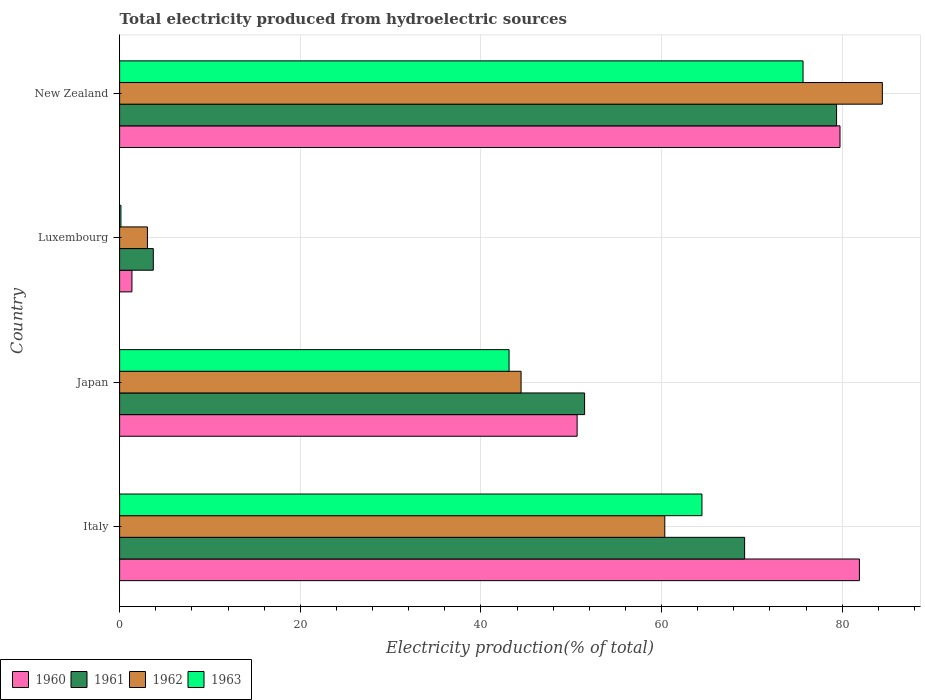How many different coloured bars are there?
Your answer should be very brief. 4. How many groups of bars are there?
Make the answer very short. 4. Are the number of bars per tick equal to the number of legend labels?
Your answer should be compact. Yes. Are the number of bars on each tick of the Y-axis equal?
Offer a terse response. Yes. How many bars are there on the 1st tick from the top?
Offer a terse response. 4. How many bars are there on the 2nd tick from the bottom?
Keep it short and to the point. 4. What is the total electricity produced in 1961 in Italy?
Ensure brevity in your answer.  69.19. Across all countries, what is the maximum total electricity produced in 1962?
Give a very brief answer. 84.44. Across all countries, what is the minimum total electricity produced in 1962?
Make the answer very short. 3.08. In which country was the total electricity produced in 1960 maximum?
Your answer should be very brief. Italy. In which country was the total electricity produced in 1961 minimum?
Offer a very short reply. Luxembourg. What is the total total electricity produced in 1961 in the graph?
Give a very brief answer. 203.77. What is the difference between the total electricity produced in 1963 in Luxembourg and that in New Zealand?
Make the answer very short. -75.51. What is the difference between the total electricity produced in 1960 in Italy and the total electricity produced in 1961 in Luxembourg?
Your answer should be very brief. 78.17. What is the average total electricity produced in 1963 per country?
Offer a very short reply. 45.85. What is the difference between the total electricity produced in 1962 and total electricity produced in 1961 in New Zealand?
Offer a terse response. 5.07. In how many countries, is the total electricity produced in 1961 greater than 44 %?
Your response must be concise. 3. What is the ratio of the total electricity produced in 1961 in Italy to that in Luxembourg?
Offer a terse response. 18.55. What is the difference between the highest and the second highest total electricity produced in 1963?
Your answer should be very brief. 11.19. What is the difference between the highest and the lowest total electricity produced in 1960?
Offer a very short reply. 80.53. Is it the case that in every country, the sum of the total electricity produced in 1961 and total electricity produced in 1960 is greater than the sum of total electricity produced in 1963 and total electricity produced in 1962?
Provide a succinct answer. No. What does the 2nd bar from the top in Japan represents?
Your response must be concise. 1962. Is it the case that in every country, the sum of the total electricity produced in 1961 and total electricity produced in 1963 is greater than the total electricity produced in 1962?
Provide a short and direct response. Yes. How many bars are there?
Make the answer very short. 16. Are all the bars in the graph horizontal?
Give a very brief answer. Yes. How many countries are there in the graph?
Offer a very short reply. 4. What is the difference between two consecutive major ticks on the X-axis?
Keep it short and to the point. 20. Are the values on the major ticks of X-axis written in scientific E-notation?
Your answer should be very brief. No. Does the graph contain any zero values?
Your answer should be compact. No. What is the title of the graph?
Offer a very short reply. Total electricity produced from hydroelectric sources. Does "2009" appear as one of the legend labels in the graph?
Make the answer very short. No. What is the label or title of the X-axis?
Your response must be concise. Electricity production(% of total). What is the Electricity production(% of total) in 1960 in Italy?
Provide a succinct answer. 81.9. What is the Electricity production(% of total) in 1961 in Italy?
Make the answer very short. 69.19. What is the Electricity production(% of total) in 1962 in Italy?
Your response must be concise. 60.35. What is the Electricity production(% of total) of 1963 in Italy?
Your response must be concise. 64.47. What is the Electricity production(% of total) of 1960 in Japan?
Give a very brief answer. 50.65. What is the Electricity production(% of total) of 1961 in Japan?
Give a very brief answer. 51.48. What is the Electricity production(% of total) of 1962 in Japan?
Provide a short and direct response. 44.44. What is the Electricity production(% of total) of 1963 in Japan?
Your answer should be compact. 43.11. What is the Electricity production(% of total) in 1960 in Luxembourg?
Give a very brief answer. 1.37. What is the Electricity production(% of total) in 1961 in Luxembourg?
Provide a succinct answer. 3.73. What is the Electricity production(% of total) of 1962 in Luxembourg?
Provide a short and direct response. 3.08. What is the Electricity production(% of total) of 1963 in Luxembourg?
Provide a short and direct response. 0.15. What is the Electricity production(% of total) in 1960 in New Zealand?
Provide a succinct answer. 79.75. What is the Electricity production(% of total) of 1961 in New Zealand?
Offer a terse response. 79.37. What is the Electricity production(% of total) of 1962 in New Zealand?
Your response must be concise. 84.44. What is the Electricity production(% of total) in 1963 in New Zealand?
Offer a very short reply. 75.66. Across all countries, what is the maximum Electricity production(% of total) in 1960?
Offer a terse response. 81.9. Across all countries, what is the maximum Electricity production(% of total) of 1961?
Your answer should be compact. 79.37. Across all countries, what is the maximum Electricity production(% of total) in 1962?
Give a very brief answer. 84.44. Across all countries, what is the maximum Electricity production(% of total) of 1963?
Provide a short and direct response. 75.66. Across all countries, what is the minimum Electricity production(% of total) of 1960?
Offer a very short reply. 1.37. Across all countries, what is the minimum Electricity production(% of total) in 1961?
Keep it short and to the point. 3.73. Across all countries, what is the minimum Electricity production(% of total) of 1962?
Your answer should be compact. 3.08. Across all countries, what is the minimum Electricity production(% of total) of 1963?
Your response must be concise. 0.15. What is the total Electricity production(% of total) of 1960 in the graph?
Provide a succinct answer. 213.67. What is the total Electricity production(% of total) in 1961 in the graph?
Keep it short and to the point. 203.77. What is the total Electricity production(% of total) of 1962 in the graph?
Give a very brief answer. 192.32. What is the total Electricity production(% of total) of 1963 in the graph?
Your response must be concise. 183.39. What is the difference between the Electricity production(% of total) in 1960 in Italy and that in Japan?
Your answer should be compact. 31.25. What is the difference between the Electricity production(% of total) in 1961 in Italy and that in Japan?
Offer a very short reply. 17.71. What is the difference between the Electricity production(% of total) of 1962 in Italy and that in Japan?
Ensure brevity in your answer.  15.91. What is the difference between the Electricity production(% of total) of 1963 in Italy and that in Japan?
Your answer should be compact. 21.35. What is the difference between the Electricity production(% of total) of 1960 in Italy and that in Luxembourg?
Provide a succinct answer. 80.53. What is the difference between the Electricity production(% of total) of 1961 in Italy and that in Luxembourg?
Provide a succinct answer. 65.46. What is the difference between the Electricity production(% of total) in 1962 in Italy and that in Luxembourg?
Make the answer very short. 57.27. What is the difference between the Electricity production(% of total) in 1963 in Italy and that in Luxembourg?
Keep it short and to the point. 64.32. What is the difference between the Electricity production(% of total) in 1960 in Italy and that in New Zealand?
Offer a terse response. 2.15. What is the difference between the Electricity production(% of total) of 1961 in Italy and that in New Zealand?
Your answer should be compact. -10.18. What is the difference between the Electricity production(% of total) in 1962 in Italy and that in New Zealand?
Keep it short and to the point. -24.08. What is the difference between the Electricity production(% of total) of 1963 in Italy and that in New Zealand?
Provide a succinct answer. -11.19. What is the difference between the Electricity production(% of total) of 1960 in Japan and that in Luxembourg?
Provide a short and direct response. 49.28. What is the difference between the Electricity production(% of total) of 1961 in Japan and that in Luxembourg?
Your answer should be compact. 47.75. What is the difference between the Electricity production(% of total) in 1962 in Japan and that in Luxembourg?
Provide a succinct answer. 41.36. What is the difference between the Electricity production(% of total) in 1963 in Japan and that in Luxembourg?
Offer a terse response. 42.97. What is the difference between the Electricity production(% of total) of 1960 in Japan and that in New Zealand?
Keep it short and to the point. -29.1. What is the difference between the Electricity production(% of total) of 1961 in Japan and that in New Zealand?
Your answer should be very brief. -27.9. What is the difference between the Electricity production(% of total) of 1962 in Japan and that in New Zealand?
Offer a very short reply. -39.99. What is the difference between the Electricity production(% of total) of 1963 in Japan and that in New Zealand?
Give a very brief answer. -32.54. What is the difference between the Electricity production(% of total) of 1960 in Luxembourg and that in New Zealand?
Make the answer very short. -78.38. What is the difference between the Electricity production(% of total) in 1961 in Luxembourg and that in New Zealand?
Offer a very short reply. -75.64. What is the difference between the Electricity production(% of total) in 1962 in Luxembourg and that in New Zealand?
Keep it short and to the point. -81.36. What is the difference between the Electricity production(% of total) in 1963 in Luxembourg and that in New Zealand?
Provide a short and direct response. -75.51. What is the difference between the Electricity production(% of total) in 1960 in Italy and the Electricity production(% of total) in 1961 in Japan?
Provide a short and direct response. 30.42. What is the difference between the Electricity production(% of total) in 1960 in Italy and the Electricity production(% of total) in 1962 in Japan?
Your answer should be very brief. 37.46. What is the difference between the Electricity production(% of total) of 1960 in Italy and the Electricity production(% of total) of 1963 in Japan?
Your answer should be very brief. 38.79. What is the difference between the Electricity production(% of total) in 1961 in Italy and the Electricity production(% of total) in 1962 in Japan?
Your answer should be compact. 24.75. What is the difference between the Electricity production(% of total) of 1961 in Italy and the Electricity production(% of total) of 1963 in Japan?
Provide a short and direct response. 26.08. What is the difference between the Electricity production(% of total) of 1962 in Italy and the Electricity production(% of total) of 1963 in Japan?
Offer a terse response. 17.24. What is the difference between the Electricity production(% of total) of 1960 in Italy and the Electricity production(% of total) of 1961 in Luxembourg?
Provide a succinct answer. 78.17. What is the difference between the Electricity production(% of total) in 1960 in Italy and the Electricity production(% of total) in 1962 in Luxembourg?
Give a very brief answer. 78.82. What is the difference between the Electricity production(% of total) in 1960 in Italy and the Electricity production(% of total) in 1963 in Luxembourg?
Your response must be concise. 81.75. What is the difference between the Electricity production(% of total) in 1961 in Italy and the Electricity production(% of total) in 1962 in Luxembourg?
Offer a very short reply. 66.11. What is the difference between the Electricity production(% of total) of 1961 in Italy and the Electricity production(% of total) of 1963 in Luxembourg?
Provide a short and direct response. 69.04. What is the difference between the Electricity production(% of total) of 1962 in Italy and the Electricity production(% of total) of 1963 in Luxembourg?
Your answer should be very brief. 60.21. What is the difference between the Electricity production(% of total) of 1960 in Italy and the Electricity production(% of total) of 1961 in New Zealand?
Offer a very short reply. 2.53. What is the difference between the Electricity production(% of total) of 1960 in Italy and the Electricity production(% of total) of 1962 in New Zealand?
Provide a short and direct response. -2.54. What is the difference between the Electricity production(% of total) in 1960 in Italy and the Electricity production(% of total) in 1963 in New Zealand?
Your answer should be very brief. 6.24. What is the difference between the Electricity production(% of total) in 1961 in Italy and the Electricity production(% of total) in 1962 in New Zealand?
Give a very brief answer. -15.25. What is the difference between the Electricity production(% of total) in 1961 in Italy and the Electricity production(% of total) in 1963 in New Zealand?
Your response must be concise. -6.47. What is the difference between the Electricity production(% of total) of 1962 in Italy and the Electricity production(% of total) of 1963 in New Zealand?
Provide a succinct answer. -15.3. What is the difference between the Electricity production(% of total) in 1960 in Japan and the Electricity production(% of total) in 1961 in Luxembourg?
Make the answer very short. 46.92. What is the difference between the Electricity production(% of total) in 1960 in Japan and the Electricity production(% of total) in 1962 in Luxembourg?
Keep it short and to the point. 47.57. What is the difference between the Electricity production(% of total) of 1960 in Japan and the Electricity production(% of total) of 1963 in Luxembourg?
Keep it short and to the point. 50.5. What is the difference between the Electricity production(% of total) in 1961 in Japan and the Electricity production(% of total) in 1962 in Luxembourg?
Your response must be concise. 48.39. What is the difference between the Electricity production(% of total) of 1961 in Japan and the Electricity production(% of total) of 1963 in Luxembourg?
Provide a succinct answer. 51.33. What is the difference between the Electricity production(% of total) in 1962 in Japan and the Electricity production(% of total) in 1963 in Luxembourg?
Provide a succinct answer. 44.3. What is the difference between the Electricity production(% of total) in 1960 in Japan and the Electricity production(% of total) in 1961 in New Zealand?
Make the answer very short. -28.72. What is the difference between the Electricity production(% of total) in 1960 in Japan and the Electricity production(% of total) in 1962 in New Zealand?
Give a very brief answer. -33.79. What is the difference between the Electricity production(% of total) of 1960 in Japan and the Electricity production(% of total) of 1963 in New Zealand?
Provide a succinct answer. -25.01. What is the difference between the Electricity production(% of total) of 1961 in Japan and the Electricity production(% of total) of 1962 in New Zealand?
Provide a succinct answer. -32.96. What is the difference between the Electricity production(% of total) of 1961 in Japan and the Electricity production(% of total) of 1963 in New Zealand?
Your response must be concise. -24.18. What is the difference between the Electricity production(% of total) of 1962 in Japan and the Electricity production(% of total) of 1963 in New Zealand?
Offer a very short reply. -31.21. What is the difference between the Electricity production(% of total) in 1960 in Luxembourg and the Electricity production(% of total) in 1961 in New Zealand?
Your answer should be compact. -78.01. What is the difference between the Electricity production(% of total) in 1960 in Luxembourg and the Electricity production(% of total) in 1962 in New Zealand?
Ensure brevity in your answer.  -83.07. What is the difference between the Electricity production(% of total) of 1960 in Luxembourg and the Electricity production(% of total) of 1963 in New Zealand?
Your answer should be very brief. -74.29. What is the difference between the Electricity production(% of total) of 1961 in Luxembourg and the Electricity production(% of total) of 1962 in New Zealand?
Your answer should be very brief. -80.71. What is the difference between the Electricity production(% of total) of 1961 in Luxembourg and the Electricity production(% of total) of 1963 in New Zealand?
Your response must be concise. -71.93. What is the difference between the Electricity production(% of total) in 1962 in Luxembourg and the Electricity production(% of total) in 1963 in New Zealand?
Make the answer very short. -72.58. What is the average Electricity production(% of total) of 1960 per country?
Offer a very short reply. 53.42. What is the average Electricity production(% of total) of 1961 per country?
Your answer should be compact. 50.94. What is the average Electricity production(% of total) in 1962 per country?
Your answer should be very brief. 48.08. What is the average Electricity production(% of total) in 1963 per country?
Your response must be concise. 45.85. What is the difference between the Electricity production(% of total) in 1960 and Electricity production(% of total) in 1961 in Italy?
Give a very brief answer. 12.71. What is the difference between the Electricity production(% of total) of 1960 and Electricity production(% of total) of 1962 in Italy?
Offer a very short reply. 21.55. What is the difference between the Electricity production(% of total) of 1960 and Electricity production(% of total) of 1963 in Italy?
Provide a succinct answer. 17.43. What is the difference between the Electricity production(% of total) in 1961 and Electricity production(% of total) in 1962 in Italy?
Give a very brief answer. 8.84. What is the difference between the Electricity production(% of total) of 1961 and Electricity production(% of total) of 1963 in Italy?
Your response must be concise. 4.72. What is the difference between the Electricity production(% of total) in 1962 and Electricity production(% of total) in 1963 in Italy?
Your answer should be compact. -4.11. What is the difference between the Electricity production(% of total) of 1960 and Electricity production(% of total) of 1961 in Japan?
Give a very brief answer. -0.83. What is the difference between the Electricity production(% of total) in 1960 and Electricity production(% of total) in 1962 in Japan?
Offer a terse response. 6.2. What is the difference between the Electricity production(% of total) of 1960 and Electricity production(% of total) of 1963 in Japan?
Provide a succinct answer. 7.54. What is the difference between the Electricity production(% of total) of 1961 and Electricity production(% of total) of 1962 in Japan?
Give a very brief answer. 7.03. What is the difference between the Electricity production(% of total) in 1961 and Electricity production(% of total) in 1963 in Japan?
Provide a short and direct response. 8.36. What is the difference between the Electricity production(% of total) in 1962 and Electricity production(% of total) in 1963 in Japan?
Your answer should be compact. 1.33. What is the difference between the Electricity production(% of total) in 1960 and Electricity production(% of total) in 1961 in Luxembourg?
Make the answer very short. -2.36. What is the difference between the Electricity production(% of total) in 1960 and Electricity production(% of total) in 1962 in Luxembourg?
Provide a succinct answer. -1.72. What is the difference between the Electricity production(% of total) of 1960 and Electricity production(% of total) of 1963 in Luxembourg?
Your answer should be compact. 1.22. What is the difference between the Electricity production(% of total) of 1961 and Electricity production(% of total) of 1962 in Luxembourg?
Your answer should be very brief. 0.65. What is the difference between the Electricity production(% of total) in 1961 and Electricity production(% of total) in 1963 in Luxembourg?
Your answer should be very brief. 3.58. What is the difference between the Electricity production(% of total) in 1962 and Electricity production(% of total) in 1963 in Luxembourg?
Offer a terse response. 2.93. What is the difference between the Electricity production(% of total) of 1960 and Electricity production(% of total) of 1961 in New Zealand?
Offer a very short reply. 0.38. What is the difference between the Electricity production(% of total) in 1960 and Electricity production(% of total) in 1962 in New Zealand?
Make the answer very short. -4.69. What is the difference between the Electricity production(% of total) in 1960 and Electricity production(% of total) in 1963 in New Zealand?
Make the answer very short. 4.09. What is the difference between the Electricity production(% of total) in 1961 and Electricity production(% of total) in 1962 in New Zealand?
Provide a short and direct response. -5.07. What is the difference between the Electricity production(% of total) of 1961 and Electricity production(% of total) of 1963 in New Zealand?
Your answer should be very brief. 3.71. What is the difference between the Electricity production(% of total) in 1962 and Electricity production(% of total) in 1963 in New Zealand?
Keep it short and to the point. 8.78. What is the ratio of the Electricity production(% of total) of 1960 in Italy to that in Japan?
Your response must be concise. 1.62. What is the ratio of the Electricity production(% of total) in 1961 in Italy to that in Japan?
Give a very brief answer. 1.34. What is the ratio of the Electricity production(% of total) of 1962 in Italy to that in Japan?
Give a very brief answer. 1.36. What is the ratio of the Electricity production(% of total) of 1963 in Italy to that in Japan?
Provide a succinct answer. 1.5. What is the ratio of the Electricity production(% of total) of 1960 in Italy to that in Luxembourg?
Keep it short and to the point. 59.95. What is the ratio of the Electricity production(% of total) in 1961 in Italy to that in Luxembourg?
Your answer should be very brief. 18.55. What is the ratio of the Electricity production(% of total) in 1962 in Italy to that in Luxembourg?
Give a very brief answer. 19.58. What is the ratio of the Electricity production(% of total) in 1963 in Italy to that in Luxembourg?
Offer a very short reply. 436.77. What is the ratio of the Electricity production(% of total) of 1960 in Italy to that in New Zealand?
Offer a very short reply. 1.03. What is the ratio of the Electricity production(% of total) of 1961 in Italy to that in New Zealand?
Give a very brief answer. 0.87. What is the ratio of the Electricity production(% of total) in 1962 in Italy to that in New Zealand?
Your answer should be very brief. 0.71. What is the ratio of the Electricity production(% of total) of 1963 in Italy to that in New Zealand?
Offer a terse response. 0.85. What is the ratio of the Electricity production(% of total) in 1960 in Japan to that in Luxembourg?
Ensure brevity in your answer.  37.08. What is the ratio of the Electricity production(% of total) of 1961 in Japan to that in Luxembourg?
Provide a short and direct response. 13.8. What is the ratio of the Electricity production(% of total) of 1962 in Japan to that in Luxembourg?
Offer a terse response. 14.42. What is the ratio of the Electricity production(% of total) in 1963 in Japan to that in Luxembourg?
Give a very brief answer. 292.1. What is the ratio of the Electricity production(% of total) in 1960 in Japan to that in New Zealand?
Your response must be concise. 0.64. What is the ratio of the Electricity production(% of total) of 1961 in Japan to that in New Zealand?
Make the answer very short. 0.65. What is the ratio of the Electricity production(% of total) in 1962 in Japan to that in New Zealand?
Make the answer very short. 0.53. What is the ratio of the Electricity production(% of total) in 1963 in Japan to that in New Zealand?
Give a very brief answer. 0.57. What is the ratio of the Electricity production(% of total) in 1960 in Luxembourg to that in New Zealand?
Offer a terse response. 0.02. What is the ratio of the Electricity production(% of total) of 1961 in Luxembourg to that in New Zealand?
Provide a succinct answer. 0.05. What is the ratio of the Electricity production(% of total) of 1962 in Luxembourg to that in New Zealand?
Provide a short and direct response. 0.04. What is the ratio of the Electricity production(% of total) of 1963 in Luxembourg to that in New Zealand?
Ensure brevity in your answer.  0. What is the difference between the highest and the second highest Electricity production(% of total) in 1960?
Your answer should be very brief. 2.15. What is the difference between the highest and the second highest Electricity production(% of total) of 1961?
Make the answer very short. 10.18. What is the difference between the highest and the second highest Electricity production(% of total) of 1962?
Provide a short and direct response. 24.08. What is the difference between the highest and the second highest Electricity production(% of total) in 1963?
Provide a short and direct response. 11.19. What is the difference between the highest and the lowest Electricity production(% of total) of 1960?
Offer a terse response. 80.53. What is the difference between the highest and the lowest Electricity production(% of total) in 1961?
Ensure brevity in your answer.  75.64. What is the difference between the highest and the lowest Electricity production(% of total) of 1962?
Give a very brief answer. 81.36. What is the difference between the highest and the lowest Electricity production(% of total) in 1963?
Your response must be concise. 75.51. 